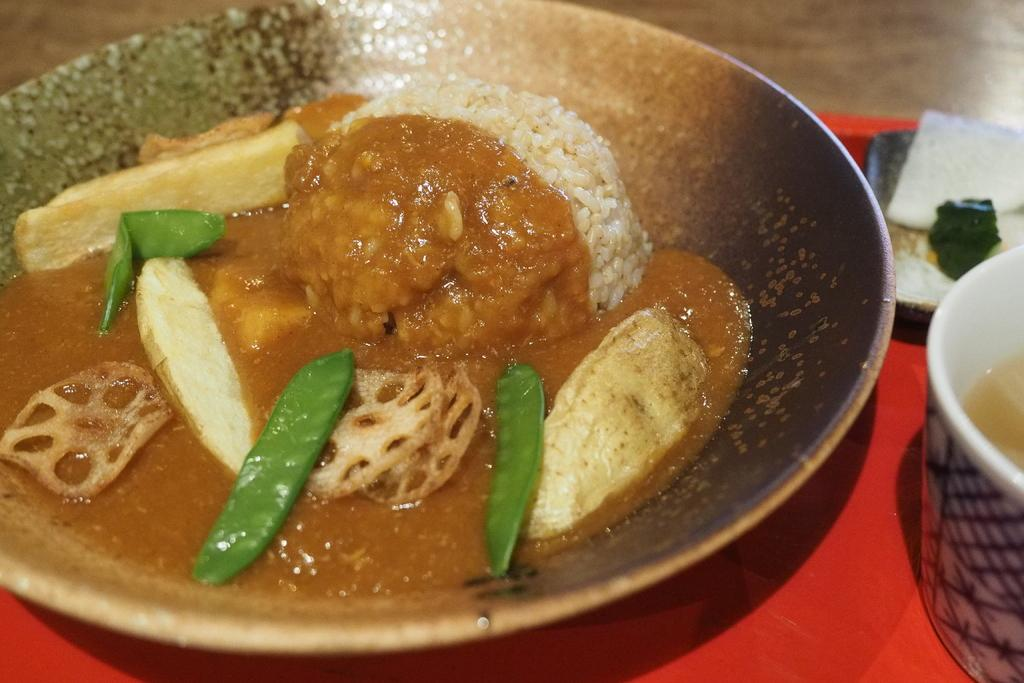What is the main food item on the plate in the image? The specific food item cannot be determined from the provided facts. What type of container is present in the image? There is a cup in the image. What other food item can be seen in the image? There is a bread piece in the image. How many knees are visible in the image? There are no knees visible in the image. Who is the representative of the food items in the image? The concept of a representative for the food items is not applicable in this context, as the image is a still representation and not a meeting or gathering. 